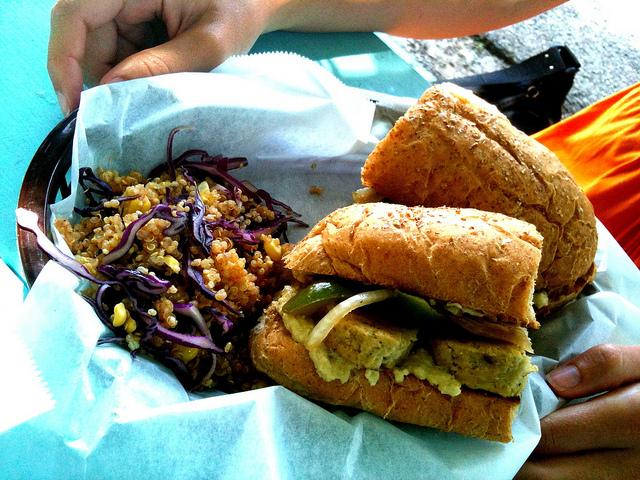What type of food is shown? Please explain your reasoning. sandwiches. Vegetables and other ingredients are being served on bread. 